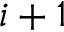<formula> <loc_0><loc_0><loc_500><loc_500>i + 1</formula> 